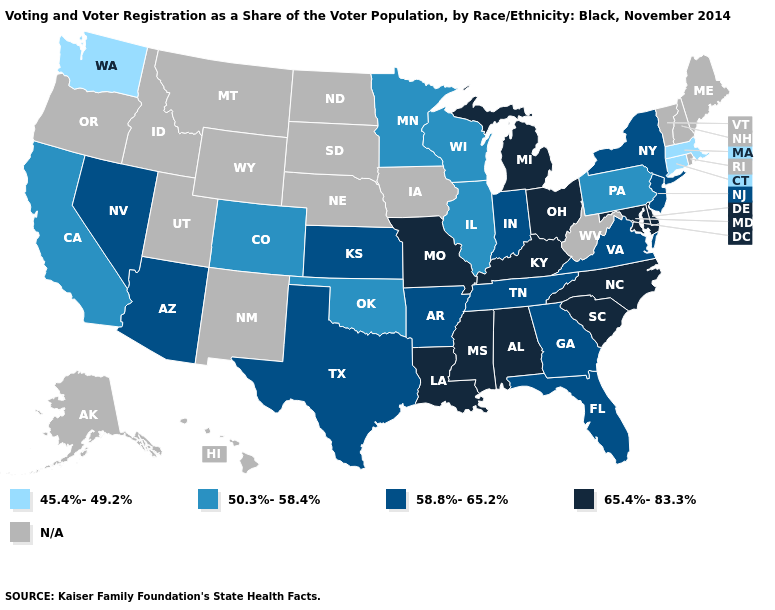Name the states that have a value in the range 50.3%-58.4%?
Quick response, please. California, Colorado, Illinois, Minnesota, Oklahoma, Pennsylvania, Wisconsin. Name the states that have a value in the range N/A?
Quick response, please. Alaska, Hawaii, Idaho, Iowa, Maine, Montana, Nebraska, New Hampshire, New Mexico, North Dakota, Oregon, Rhode Island, South Dakota, Utah, Vermont, West Virginia, Wyoming. What is the value of Idaho?
Quick response, please. N/A. Does the map have missing data?
Answer briefly. Yes. What is the value of Montana?
Quick response, please. N/A. Which states have the highest value in the USA?
Write a very short answer. Alabama, Delaware, Kentucky, Louisiana, Maryland, Michigan, Mississippi, Missouri, North Carolina, Ohio, South Carolina. Name the states that have a value in the range 45.4%-49.2%?
Write a very short answer. Connecticut, Massachusetts, Washington. What is the value of Nebraska?
Be succinct. N/A. Name the states that have a value in the range N/A?
Answer briefly. Alaska, Hawaii, Idaho, Iowa, Maine, Montana, Nebraska, New Hampshire, New Mexico, North Dakota, Oregon, Rhode Island, South Dakota, Utah, Vermont, West Virginia, Wyoming. Does the first symbol in the legend represent the smallest category?
Quick response, please. Yes. What is the value of Georgia?
Short answer required. 58.8%-65.2%. Name the states that have a value in the range 50.3%-58.4%?
Write a very short answer. California, Colorado, Illinois, Minnesota, Oklahoma, Pennsylvania, Wisconsin. What is the value of Arkansas?
Quick response, please. 58.8%-65.2%. Among the states that border New Jersey , which have the lowest value?
Keep it brief. Pennsylvania. What is the lowest value in states that border Rhode Island?
Answer briefly. 45.4%-49.2%. 